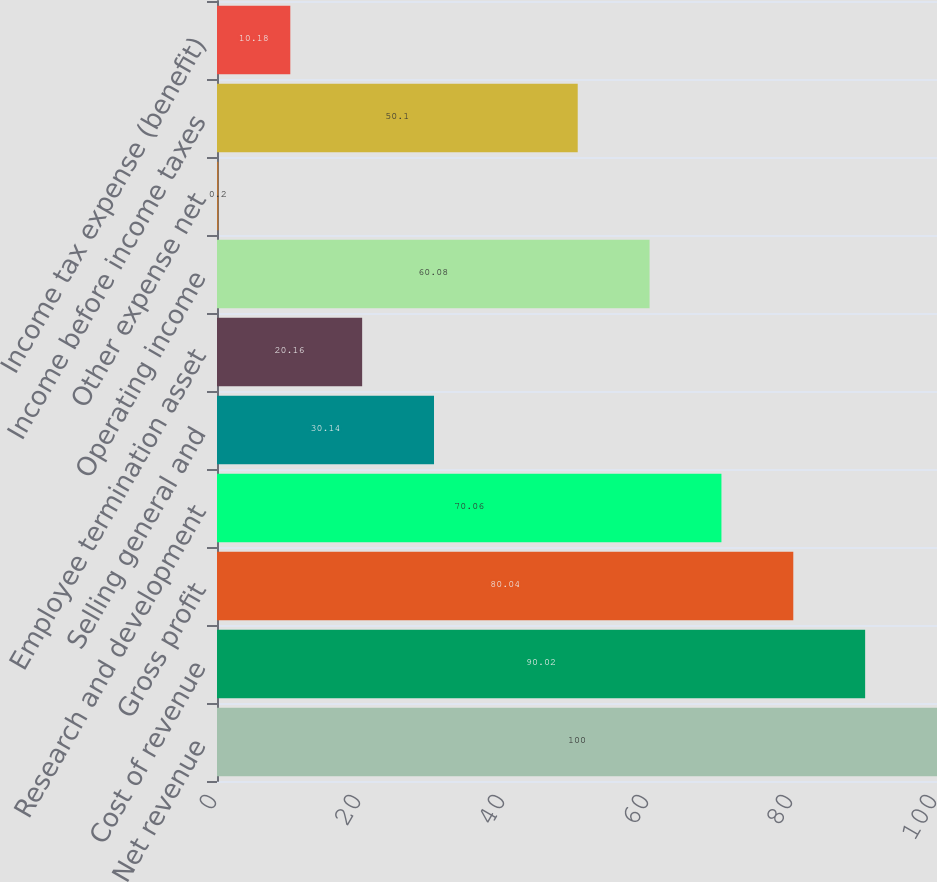Convert chart. <chart><loc_0><loc_0><loc_500><loc_500><bar_chart><fcel>Net revenue<fcel>Cost of revenue<fcel>Gross profit<fcel>Research and development<fcel>Selling general and<fcel>Employee termination asset<fcel>Operating income<fcel>Other expense net<fcel>Income before income taxes<fcel>Income tax expense (benefit)<nl><fcel>100<fcel>90.02<fcel>80.04<fcel>70.06<fcel>30.14<fcel>20.16<fcel>60.08<fcel>0.2<fcel>50.1<fcel>10.18<nl></chart> 